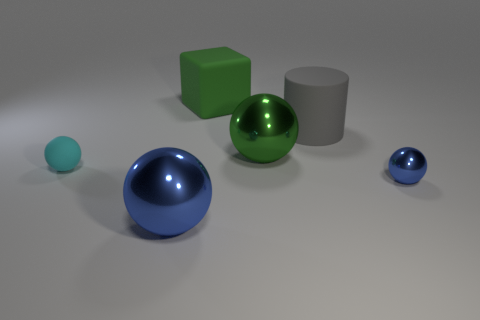Given the composition, what might be the focal point of this image? The composition seems to draw the eye towards the vibrant blue sphere in the foreground because of its size and saturated color, which contrasts with the rest of the objects and makes it a likely candidate for the focal point of the image. 